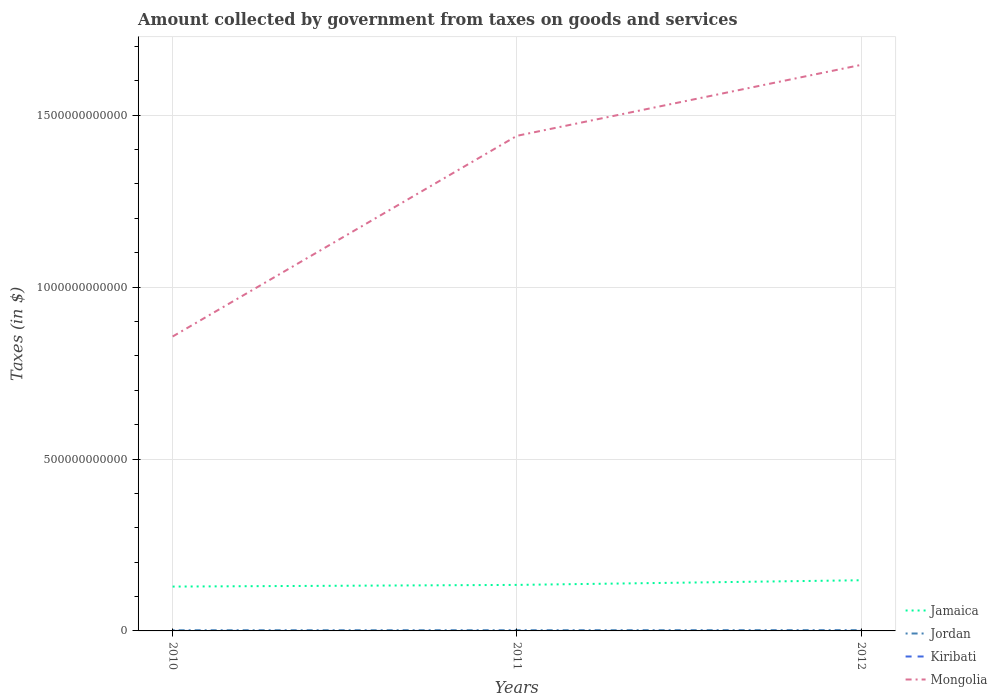How many different coloured lines are there?
Ensure brevity in your answer.  4. Does the line corresponding to Kiribati intersect with the line corresponding to Jamaica?
Your answer should be compact. No. Is the number of lines equal to the number of legend labels?
Offer a very short reply. Yes. Across all years, what is the maximum amount collected by government from taxes on goods and services in Jamaica?
Your answer should be very brief. 1.29e+11. In which year was the amount collected by government from taxes on goods and services in Jordan maximum?
Ensure brevity in your answer.  2010. What is the total amount collected by government from taxes on goods and services in Jordan in the graph?
Your answer should be compact. -3.53e+07. What is the difference between the highest and the second highest amount collected by government from taxes on goods and services in Kiribati?
Offer a very short reply. 1.49e+05. How many lines are there?
Your answer should be compact. 4. What is the difference between two consecutive major ticks on the Y-axis?
Provide a short and direct response. 5.00e+11. Does the graph contain any zero values?
Your answer should be compact. No. Does the graph contain grids?
Your response must be concise. Yes. How are the legend labels stacked?
Offer a very short reply. Vertical. What is the title of the graph?
Offer a terse response. Amount collected by government from taxes on goods and services. What is the label or title of the X-axis?
Your response must be concise. Years. What is the label or title of the Y-axis?
Provide a succinct answer. Taxes (in $). What is the Taxes (in $) in Jamaica in 2010?
Ensure brevity in your answer.  1.29e+11. What is the Taxes (in $) in Jordan in 2010?
Your answer should be very brief. 2.00e+09. What is the Taxes (in $) of Kiribati in 2010?
Your answer should be very brief. 2.22e+05. What is the Taxes (in $) of Mongolia in 2010?
Keep it short and to the point. 8.56e+11. What is the Taxes (in $) in Jamaica in 2011?
Your answer should be compact. 1.34e+11. What is the Taxes (in $) in Jordan in 2011?
Offer a very short reply. 2.03e+09. What is the Taxes (in $) of Kiribati in 2011?
Your answer should be very brief. 7.46e+04. What is the Taxes (in $) in Mongolia in 2011?
Keep it short and to the point. 1.44e+12. What is the Taxes (in $) of Jamaica in 2012?
Your answer should be compact. 1.47e+11. What is the Taxes (in $) of Jordan in 2012?
Your answer should be compact. 2.27e+09. What is the Taxes (in $) in Kiribati in 2012?
Your response must be concise. 7.29e+04. What is the Taxes (in $) of Mongolia in 2012?
Keep it short and to the point. 1.65e+12. Across all years, what is the maximum Taxes (in $) in Jamaica?
Your answer should be compact. 1.47e+11. Across all years, what is the maximum Taxes (in $) in Jordan?
Provide a succinct answer. 2.27e+09. Across all years, what is the maximum Taxes (in $) of Kiribati?
Provide a short and direct response. 2.22e+05. Across all years, what is the maximum Taxes (in $) of Mongolia?
Offer a very short reply. 1.65e+12. Across all years, what is the minimum Taxes (in $) in Jamaica?
Make the answer very short. 1.29e+11. Across all years, what is the minimum Taxes (in $) of Jordan?
Ensure brevity in your answer.  2.00e+09. Across all years, what is the minimum Taxes (in $) of Kiribati?
Keep it short and to the point. 7.29e+04. Across all years, what is the minimum Taxes (in $) of Mongolia?
Make the answer very short. 8.56e+11. What is the total Taxes (in $) of Jamaica in the graph?
Your response must be concise. 4.10e+11. What is the total Taxes (in $) of Jordan in the graph?
Give a very brief answer. 6.31e+09. What is the total Taxes (in $) in Kiribati in the graph?
Make the answer very short. 3.69e+05. What is the total Taxes (in $) of Mongolia in the graph?
Give a very brief answer. 3.94e+12. What is the difference between the Taxes (in $) of Jamaica in 2010 and that in 2011?
Offer a very short reply. -4.85e+09. What is the difference between the Taxes (in $) of Jordan in 2010 and that in 2011?
Your response must be concise. -3.53e+07. What is the difference between the Taxes (in $) in Kiribati in 2010 and that in 2011?
Provide a short and direct response. 1.47e+05. What is the difference between the Taxes (in $) of Mongolia in 2010 and that in 2011?
Your answer should be compact. -5.84e+11. What is the difference between the Taxes (in $) in Jamaica in 2010 and that in 2012?
Your answer should be compact. -1.84e+1. What is the difference between the Taxes (in $) in Jordan in 2010 and that in 2012?
Your answer should be compact. -2.77e+08. What is the difference between the Taxes (in $) of Kiribati in 2010 and that in 2012?
Offer a terse response. 1.49e+05. What is the difference between the Taxes (in $) of Mongolia in 2010 and that in 2012?
Provide a short and direct response. -7.90e+11. What is the difference between the Taxes (in $) in Jamaica in 2011 and that in 2012?
Give a very brief answer. -1.35e+1. What is the difference between the Taxes (in $) in Jordan in 2011 and that in 2012?
Keep it short and to the point. -2.42e+08. What is the difference between the Taxes (in $) of Kiribati in 2011 and that in 2012?
Keep it short and to the point. 1687.54. What is the difference between the Taxes (in $) of Mongolia in 2011 and that in 2012?
Ensure brevity in your answer.  -2.06e+11. What is the difference between the Taxes (in $) of Jamaica in 2010 and the Taxes (in $) of Jordan in 2011?
Make the answer very short. 1.27e+11. What is the difference between the Taxes (in $) of Jamaica in 2010 and the Taxes (in $) of Kiribati in 2011?
Keep it short and to the point. 1.29e+11. What is the difference between the Taxes (in $) in Jamaica in 2010 and the Taxes (in $) in Mongolia in 2011?
Provide a succinct answer. -1.31e+12. What is the difference between the Taxes (in $) in Jordan in 2010 and the Taxes (in $) in Kiribati in 2011?
Provide a short and direct response. 2.00e+09. What is the difference between the Taxes (in $) in Jordan in 2010 and the Taxes (in $) in Mongolia in 2011?
Your response must be concise. -1.44e+12. What is the difference between the Taxes (in $) of Kiribati in 2010 and the Taxes (in $) of Mongolia in 2011?
Ensure brevity in your answer.  -1.44e+12. What is the difference between the Taxes (in $) of Jamaica in 2010 and the Taxes (in $) of Jordan in 2012?
Offer a terse response. 1.27e+11. What is the difference between the Taxes (in $) of Jamaica in 2010 and the Taxes (in $) of Kiribati in 2012?
Offer a terse response. 1.29e+11. What is the difference between the Taxes (in $) in Jamaica in 2010 and the Taxes (in $) in Mongolia in 2012?
Give a very brief answer. -1.52e+12. What is the difference between the Taxes (in $) in Jordan in 2010 and the Taxes (in $) in Kiribati in 2012?
Provide a succinct answer. 2.00e+09. What is the difference between the Taxes (in $) of Jordan in 2010 and the Taxes (in $) of Mongolia in 2012?
Your answer should be compact. -1.64e+12. What is the difference between the Taxes (in $) in Kiribati in 2010 and the Taxes (in $) in Mongolia in 2012?
Provide a succinct answer. -1.65e+12. What is the difference between the Taxes (in $) in Jamaica in 2011 and the Taxes (in $) in Jordan in 2012?
Offer a very short reply. 1.32e+11. What is the difference between the Taxes (in $) in Jamaica in 2011 and the Taxes (in $) in Kiribati in 2012?
Ensure brevity in your answer.  1.34e+11. What is the difference between the Taxes (in $) in Jamaica in 2011 and the Taxes (in $) in Mongolia in 2012?
Offer a very short reply. -1.51e+12. What is the difference between the Taxes (in $) of Jordan in 2011 and the Taxes (in $) of Kiribati in 2012?
Provide a short and direct response. 2.03e+09. What is the difference between the Taxes (in $) in Jordan in 2011 and the Taxes (in $) in Mongolia in 2012?
Offer a very short reply. -1.64e+12. What is the difference between the Taxes (in $) in Kiribati in 2011 and the Taxes (in $) in Mongolia in 2012?
Make the answer very short. -1.65e+12. What is the average Taxes (in $) of Jamaica per year?
Make the answer very short. 1.37e+11. What is the average Taxes (in $) in Jordan per year?
Ensure brevity in your answer.  2.10e+09. What is the average Taxes (in $) of Kiribati per year?
Your response must be concise. 1.23e+05. What is the average Taxes (in $) of Mongolia per year?
Your answer should be very brief. 1.31e+12. In the year 2010, what is the difference between the Taxes (in $) of Jamaica and Taxes (in $) of Jordan?
Your answer should be very brief. 1.27e+11. In the year 2010, what is the difference between the Taxes (in $) of Jamaica and Taxes (in $) of Kiribati?
Provide a succinct answer. 1.29e+11. In the year 2010, what is the difference between the Taxes (in $) of Jamaica and Taxes (in $) of Mongolia?
Keep it short and to the point. -7.27e+11. In the year 2010, what is the difference between the Taxes (in $) of Jordan and Taxes (in $) of Kiribati?
Provide a short and direct response. 2.00e+09. In the year 2010, what is the difference between the Taxes (in $) of Jordan and Taxes (in $) of Mongolia?
Your answer should be compact. -8.54e+11. In the year 2010, what is the difference between the Taxes (in $) in Kiribati and Taxes (in $) in Mongolia?
Give a very brief answer. -8.56e+11. In the year 2011, what is the difference between the Taxes (in $) in Jamaica and Taxes (in $) in Jordan?
Give a very brief answer. 1.32e+11. In the year 2011, what is the difference between the Taxes (in $) in Jamaica and Taxes (in $) in Kiribati?
Your answer should be compact. 1.34e+11. In the year 2011, what is the difference between the Taxes (in $) in Jamaica and Taxes (in $) in Mongolia?
Offer a very short reply. -1.31e+12. In the year 2011, what is the difference between the Taxes (in $) in Jordan and Taxes (in $) in Kiribati?
Provide a short and direct response. 2.03e+09. In the year 2011, what is the difference between the Taxes (in $) in Jordan and Taxes (in $) in Mongolia?
Your answer should be very brief. -1.44e+12. In the year 2011, what is the difference between the Taxes (in $) in Kiribati and Taxes (in $) in Mongolia?
Provide a succinct answer. -1.44e+12. In the year 2012, what is the difference between the Taxes (in $) of Jamaica and Taxes (in $) of Jordan?
Provide a succinct answer. 1.45e+11. In the year 2012, what is the difference between the Taxes (in $) of Jamaica and Taxes (in $) of Kiribati?
Keep it short and to the point. 1.47e+11. In the year 2012, what is the difference between the Taxes (in $) of Jamaica and Taxes (in $) of Mongolia?
Provide a short and direct response. -1.50e+12. In the year 2012, what is the difference between the Taxes (in $) of Jordan and Taxes (in $) of Kiribati?
Your answer should be compact. 2.27e+09. In the year 2012, what is the difference between the Taxes (in $) of Jordan and Taxes (in $) of Mongolia?
Offer a terse response. -1.64e+12. In the year 2012, what is the difference between the Taxes (in $) in Kiribati and Taxes (in $) in Mongolia?
Make the answer very short. -1.65e+12. What is the ratio of the Taxes (in $) in Jamaica in 2010 to that in 2011?
Make the answer very short. 0.96. What is the ratio of the Taxes (in $) of Jordan in 2010 to that in 2011?
Provide a short and direct response. 0.98. What is the ratio of the Taxes (in $) of Kiribati in 2010 to that in 2011?
Your answer should be compact. 2.97. What is the ratio of the Taxes (in $) in Mongolia in 2010 to that in 2011?
Offer a terse response. 0.59. What is the ratio of the Taxes (in $) in Jamaica in 2010 to that in 2012?
Provide a succinct answer. 0.88. What is the ratio of the Taxes (in $) of Jordan in 2010 to that in 2012?
Offer a very short reply. 0.88. What is the ratio of the Taxes (in $) in Kiribati in 2010 to that in 2012?
Offer a very short reply. 3.04. What is the ratio of the Taxes (in $) of Mongolia in 2010 to that in 2012?
Provide a short and direct response. 0.52. What is the ratio of the Taxes (in $) in Jamaica in 2011 to that in 2012?
Provide a short and direct response. 0.91. What is the ratio of the Taxes (in $) in Jordan in 2011 to that in 2012?
Offer a very short reply. 0.89. What is the ratio of the Taxes (in $) in Kiribati in 2011 to that in 2012?
Your answer should be very brief. 1.02. What is the ratio of the Taxes (in $) of Mongolia in 2011 to that in 2012?
Make the answer very short. 0.87. What is the difference between the highest and the second highest Taxes (in $) in Jamaica?
Provide a short and direct response. 1.35e+1. What is the difference between the highest and the second highest Taxes (in $) in Jordan?
Keep it short and to the point. 2.42e+08. What is the difference between the highest and the second highest Taxes (in $) of Kiribati?
Offer a terse response. 1.47e+05. What is the difference between the highest and the second highest Taxes (in $) of Mongolia?
Ensure brevity in your answer.  2.06e+11. What is the difference between the highest and the lowest Taxes (in $) in Jamaica?
Give a very brief answer. 1.84e+1. What is the difference between the highest and the lowest Taxes (in $) of Jordan?
Your response must be concise. 2.77e+08. What is the difference between the highest and the lowest Taxes (in $) of Kiribati?
Offer a very short reply. 1.49e+05. What is the difference between the highest and the lowest Taxes (in $) in Mongolia?
Your response must be concise. 7.90e+11. 